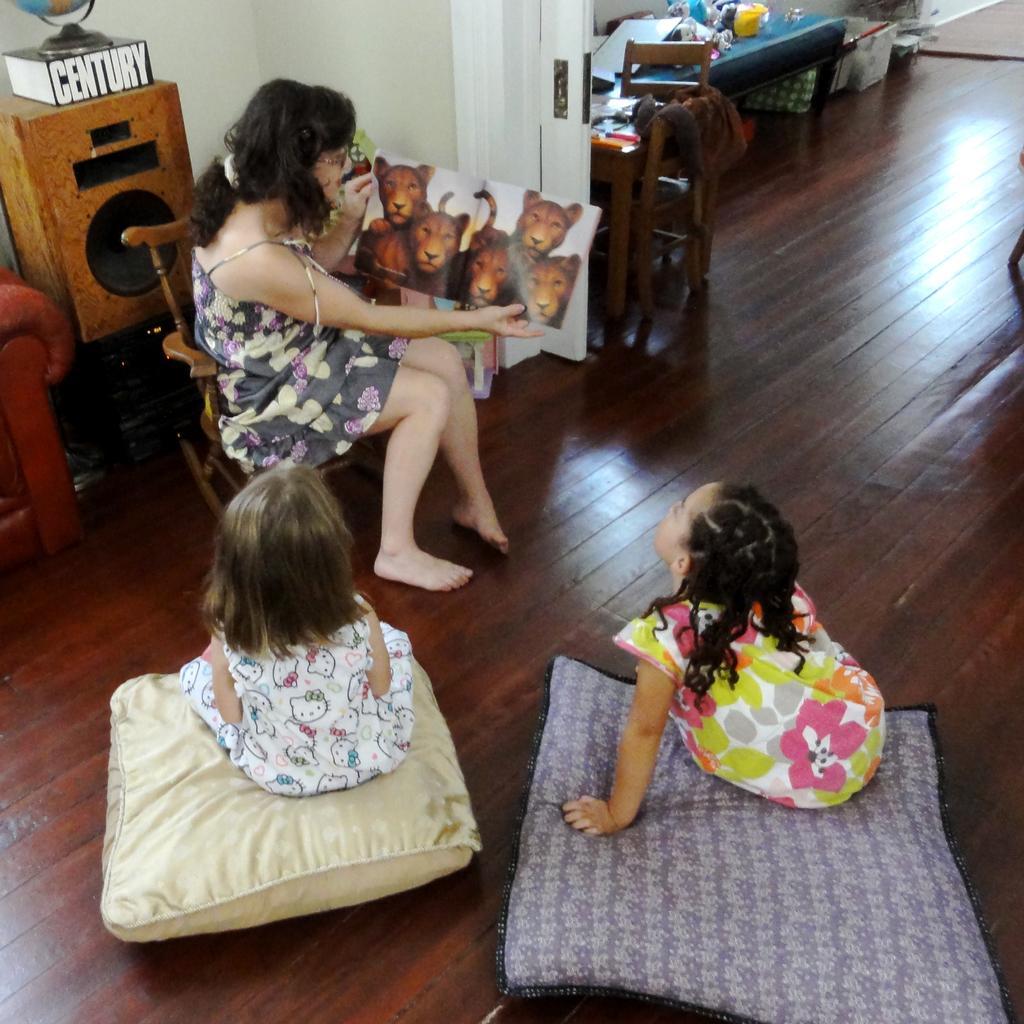Can you describe this image briefly? This is the picture inside of the room. There are two girls sitting on the pillow on the floor. There is a person sitting on the chair and she is holding the poster. At the back there is a speaker and at the left there is sofa. 